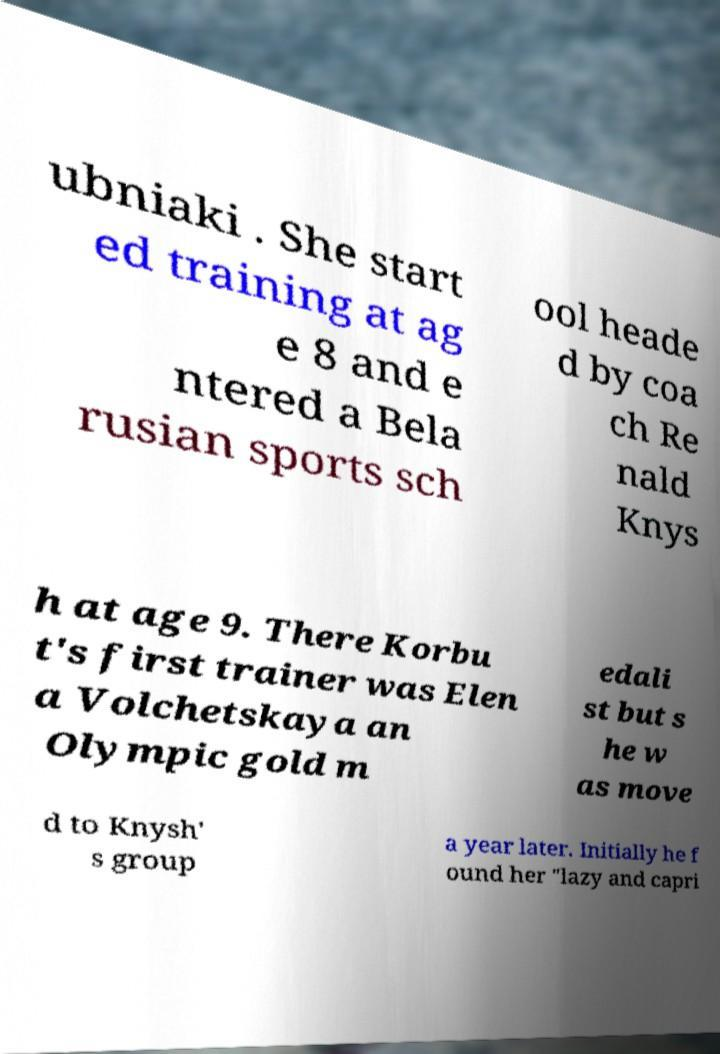Please read and relay the text visible in this image. What does it say? ubniaki . She start ed training at ag e 8 and e ntered a Bela rusian sports sch ool heade d by coa ch Re nald Knys h at age 9. There Korbu t's first trainer was Elen a Volchetskaya an Olympic gold m edali st but s he w as move d to Knysh' s group a year later. Initially he f ound her "lazy and capri 